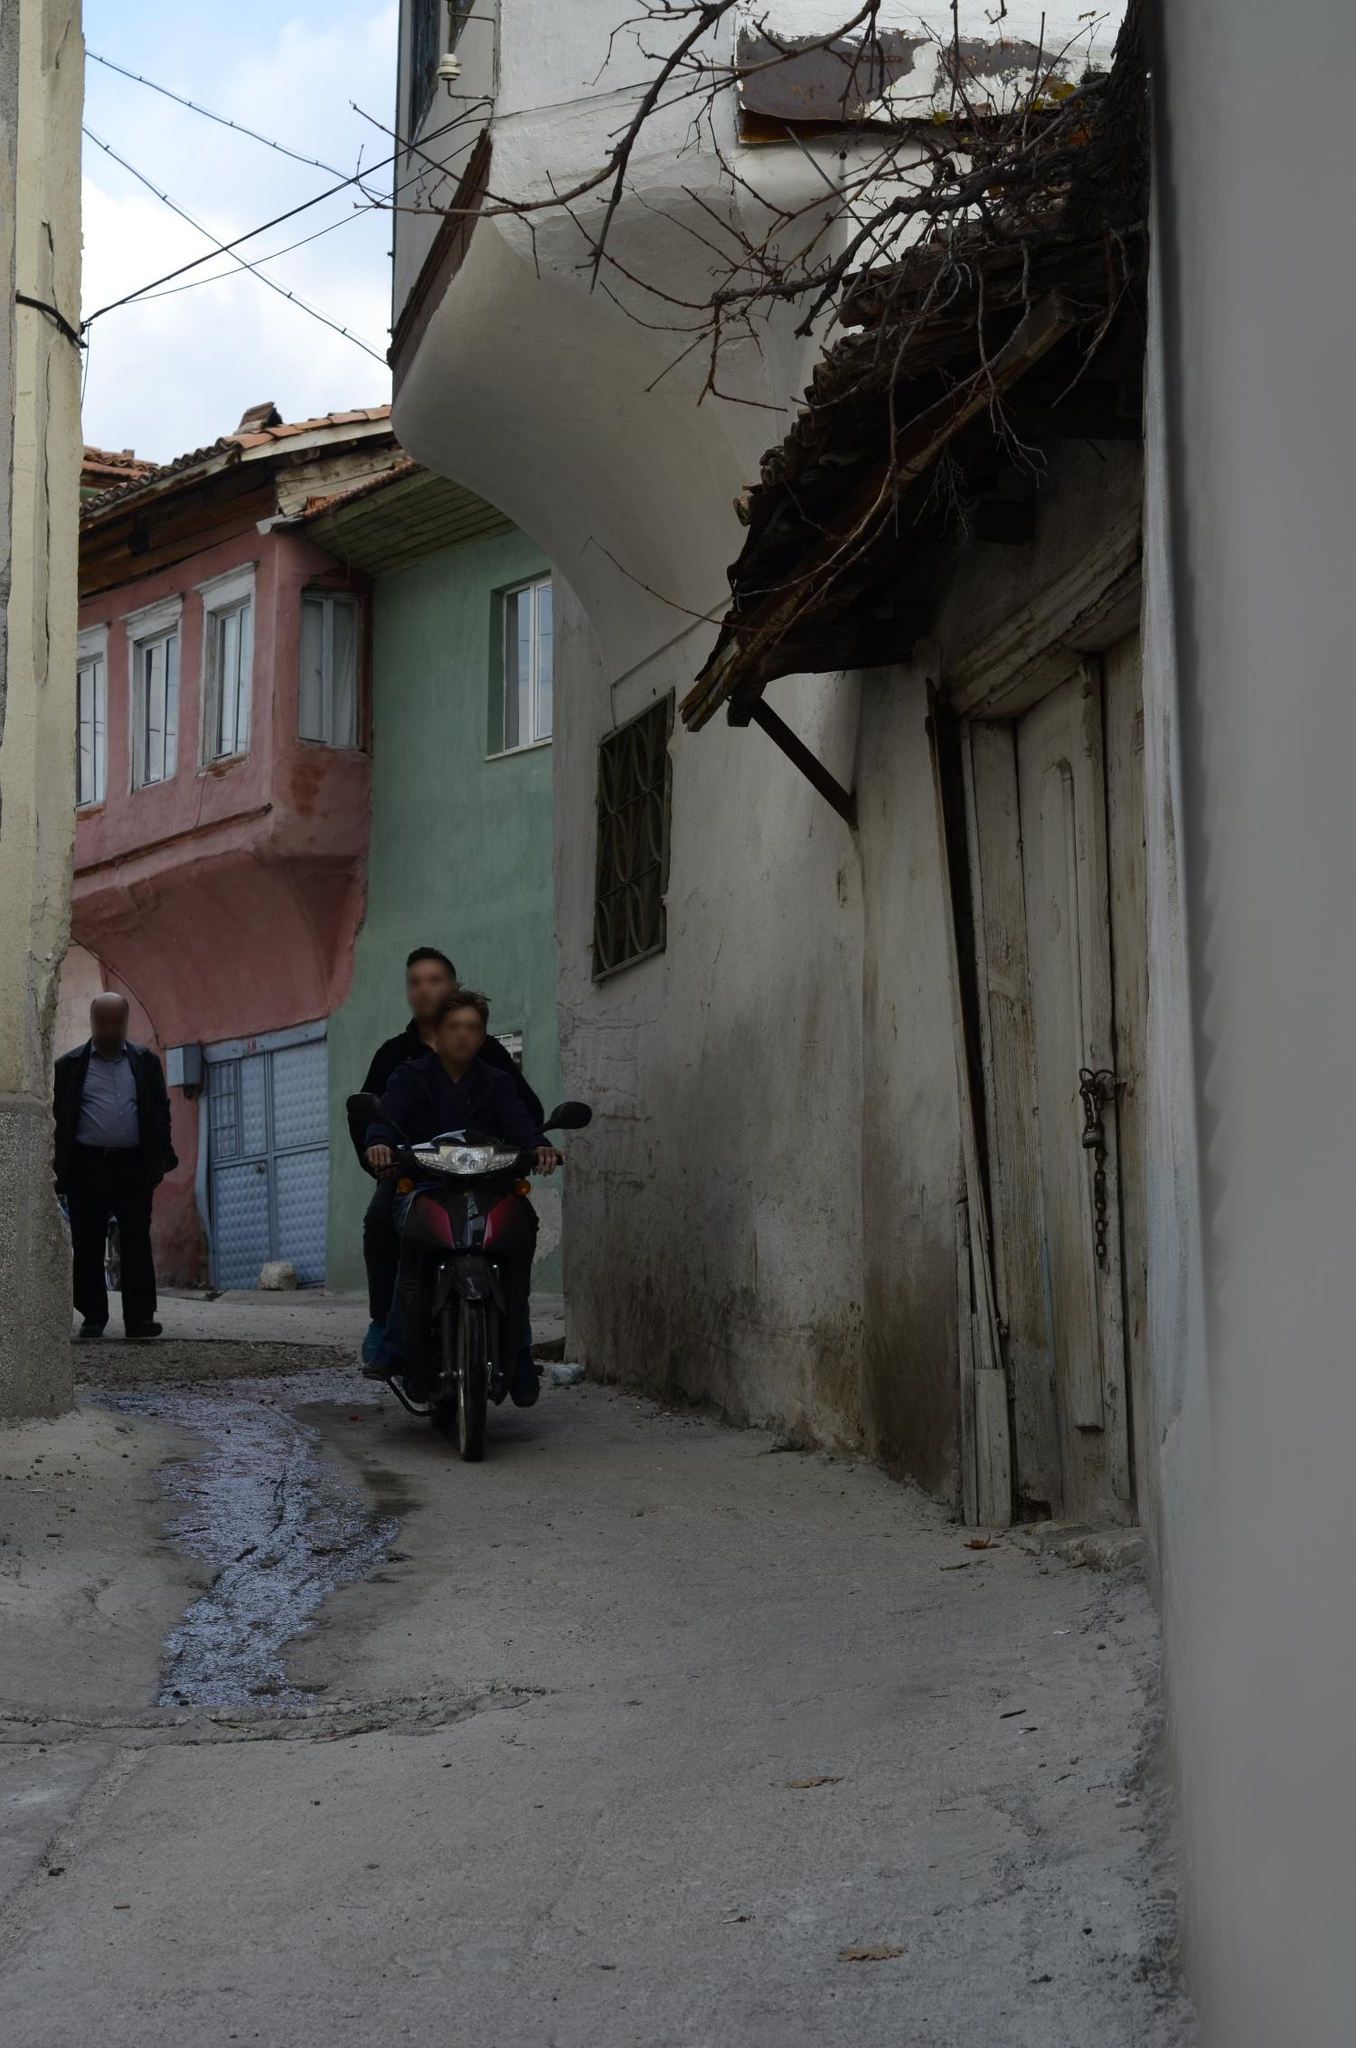What do you see happening in this image? The image depicts a vibrant and possibly historical narrow street, capturing daily life in a quaint neighborhood. The street is surrounded by pastel-colored houses displaying a variety of architectural details that suggest a rich history. A man on a motorcycle, likely a local, navigates the uneven cobblestone street, adding movement to the scene. Another man, walking behind, appears immersed in the ambiance of the locality, perhaps on his way to a nearby shop or a neighbor's house. The perspective offered by the image, shot from a low angle, introduces a dynamic view of the eroding buildings and overhead utility lines, suggesting a blend of traditional living with the pressures of modern infrastructure. Despite the wear shown by some facades, the area has a charming character, possibly indicative of a close-knit community. 